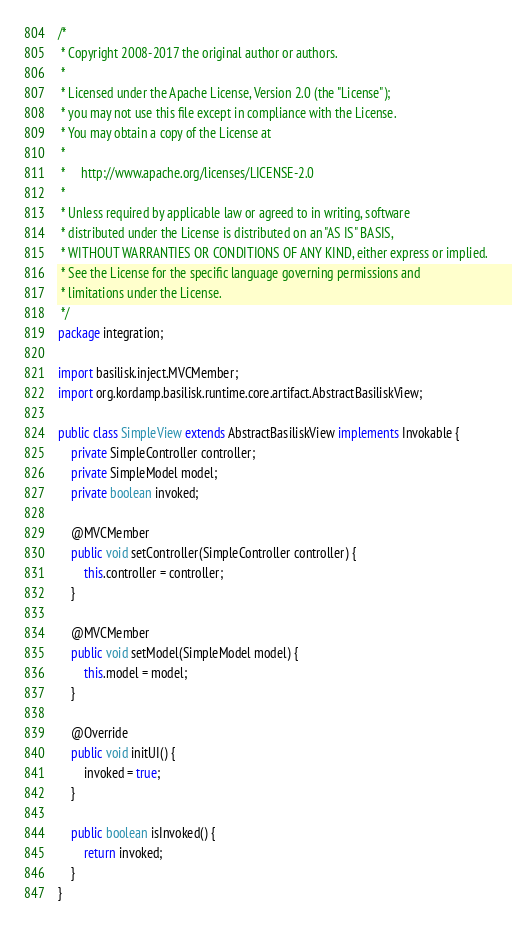<code> <loc_0><loc_0><loc_500><loc_500><_Java_>/*
 * Copyright 2008-2017 the original author or authors.
 *
 * Licensed under the Apache License, Version 2.0 (the "License");
 * you may not use this file except in compliance with the License.
 * You may obtain a copy of the License at
 *
 *     http://www.apache.org/licenses/LICENSE-2.0
 *
 * Unless required by applicable law or agreed to in writing, software
 * distributed under the License is distributed on an "AS IS" BASIS,
 * WITHOUT WARRANTIES OR CONDITIONS OF ANY KIND, either express or implied.
 * See the License for the specific language governing permissions and
 * limitations under the License.
 */
package integration;

import basilisk.inject.MVCMember;
import org.kordamp.basilisk.runtime.core.artifact.AbstractBasiliskView;

public class SimpleView extends AbstractBasiliskView implements Invokable {
    private SimpleController controller;
    private SimpleModel model;
    private boolean invoked;

    @MVCMember
    public void setController(SimpleController controller) {
        this.controller = controller;
    }

    @MVCMember
    public void setModel(SimpleModel model) {
        this.model = model;
    }

    @Override
    public void initUI() {
        invoked = true;
    }

    public boolean isInvoked() {
        return invoked;
    }
}
</code> 